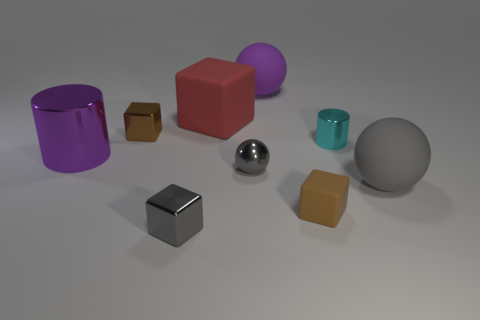Add 1 big purple cubes. How many objects exist? 10 Subtract all cylinders. How many objects are left? 7 Add 5 tiny brown shiny blocks. How many tiny brown shiny blocks exist? 6 Subtract 0 cyan blocks. How many objects are left? 9 Subtract all tiny brown rubber objects. Subtract all matte things. How many objects are left? 4 Add 5 tiny cyan things. How many tiny cyan things are left? 6 